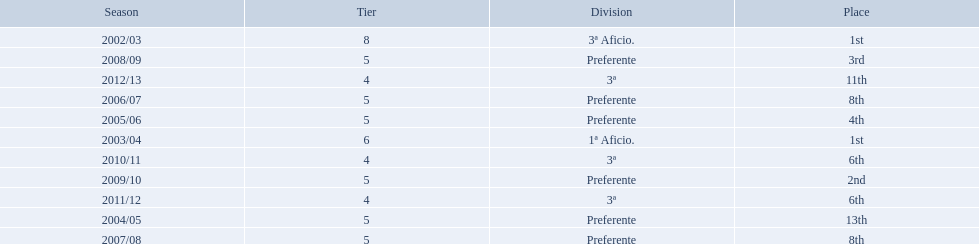What place did the team place in 2010/11? 6th. Write the full table. {'header': ['Season', 'Tier', 'Division', 'Place'], 'rows': [['2002/03', '8', '3ª Aficio.', '1st'], ['2008/09', '5', 'Preferente', '3rd'], ['2012/13', '4', '3ª', '11th'], ['2006/07', '5', 'Preferente', '8th'], ['2005/06', '5', 'Preferente', '4th'], ['2003/04', '6', '1ª Aficio.', '1st'], ['2010/11', '4', '3ª', '6th'], ['2009/10', '5', 'Preferente', '2nd'], ['2011/12', '4', '3ª', '6th'], ['2004/05', '5', 'Preferente', '13th'], ['2007/08', '5', 'Preferente', '8th']]} In what other year did they place 6th? 2011/12. 